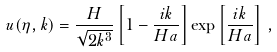Convert formula to latex. <formula><loc_0><loc_0><loc_500><loc_500>u ( \eta , k ) = \frac { H } { \sqrt { 2 k ^ { 3 } } } \left [ 1 - \frac { i k } { H a } \right ] \exp \left [ \frac { i k } { H a } \right ] \, ,</formula> 